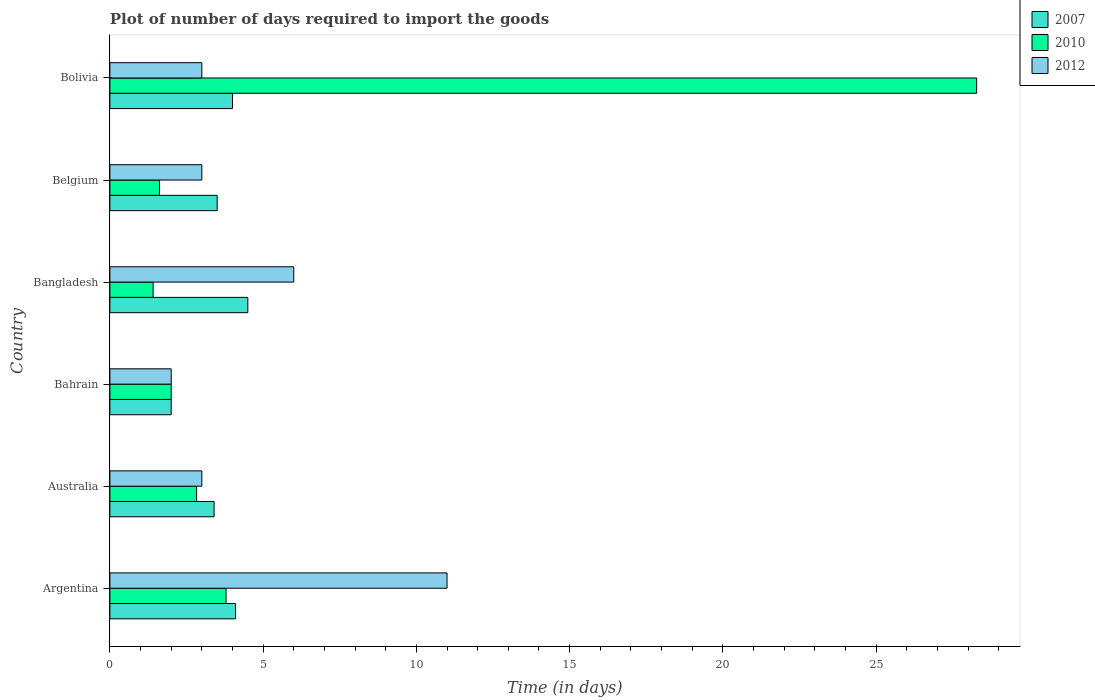How many groups of bars are there?
Offer a very short reply. 6. Are the number of bars on each tick of the Y-axis equal?
Offer a very short reply. Yes. How many bars are there on the 3rd tick from the top?
Your response must be concise. 3. How many bars are there on the 2nd tick from the bottom?
Make the answer very short. 3. What is the time required to import goods in 2010 in Bahrain?
Give a very brief answer. 2. Across all countries, what is the maximum time required to import goods in 2010?
Provide a succinct answer. 28.28. In which country was the time required to import goods in 2007 maximum?
Give a very brief answer. Bangladesh. In which country was the time required to import goods in 2007 minimum?
Offer a very short reply. Bahrain. What is the difference between the time required to import goods in 2007 in Bahrain and that in Bangladesh?
Offer a very short reply. -2.5. What is the difference between the time required to import goods in 2012 in Bangladesh and the time required to import goods in 2010 in Bolivia?
Ensure brevity in your answer.  -22.28. What is the average time required to import goods in 2012 per country?
Your answer should be very brief. 4.67. What is the difference between the time required to import goods in 2010 and time required to import goods in 2012 in Bolivia?
Offer a very short reply. 25.28. What is the ratio of the time required to import goods in 2007 in Australia to that in Bangladesh?
Your answer should be very brief. 0.76. Is the time required to import goods in 2012 in Bangladesh less than that in Bolivia?
Make the answer very short. No. Is the difference between the time required to import goods in 2010 in Australia and Bangladesh greater than the difference between the time required to import goods in 2012 in Australia and Bangladesh?
Provide a succinct answer. Yes. What is the difference between the highest and the second highest time required to import goods in 2010?
Make the answer very short. 24.49. Is it the case that in every country, the sum of the time required to import goods in 2007 and time required to import goods in 2012 is greater than the time required to import goods in 2010?
Your answer should be compact. No. How many bars are there?
Offer a very short reply. 18. How many countries are there in the graph?
Your response must be concise. 6. Are the values on the major ticks of X-axis written in scientific E-notation?
Keep it short and to the point. No. Does the graph contain grids?
Offer a very short reply. No. How many legend labels are there?
Your answer should be very brief. 3. How are the legend labels stacked?
Offer a terse response. Vertical. What is the title of the graph?
Keep it short and to the point. Plot of number of days required to import the goods. Does "1999" appear as one of the legend labels in the graph?
Offer a very short reply. No. What is the label or title of the X-axis?
Offer a terse response. Time (in days). What is the Time (in days) of 2010 in Argentina?
Your answer should be very brief. 3.79. What is the Time (in days) of 2012 in Argentina?
Give a very brief answer. 11. What is the Time (in days) of 2010 in Australia?
Your answer should be compact. 2.83. What is the Time (in days) of 2007 in Bahrain?
Make the answer very short. 2. What is the Time (in days) in 2010 in Bahrain?
Provide a succinct answer. 2. What is the Time (in days) of 2012 in Bahrain?
Give a very brief answer. 2. What is the Time (in days) in 2010 in Bangladesh?
Your answer should be compact. 1.41. What is the Time (in days) of 2012 in Bangladesh?
Give a very brief answer. 6. What is the Time (in days) of 2007 in Belgium?
Offer a very short reply. 3.5. What is the Time (in days) in 2010 in Belgium?
Your answer should be very brief. 1.62. What is the Time (in days) in 2012 in Belgium?
Provide a succinct answer. 3. What is the Time (in days) in 2007 in Bolivia?
Your answer should be very brief. 4. What is the Time (in days) of 2010 in Bolivia?
Your answer should be very brief. 28.28. What is the Time (in days) of 2012 in Bolivia?
Your answer should be compact. 3. Across all countries, what is the maximum Time (in days) in 2010?
Provide a succinct answer. 28.28. Across all countries, what is the minimum Time (in days) of 2010?
Provide a succinct answer. 1.41. Across all countries, what is the minimum Time (in days) in 2012?
Your answer should be very brief. 2. What is the total Time (in days) in 2010 in the graph?
Give a very brief answer. 39.93. What is the difference between the Time (in days) in 2007 in Argentina and that in Australia?
Make the answer very short. 0.7. What is the difference between the Time (in days) of 2012 in Argentina and that in Australia?
Your answer should be compact. 8. What is the difference between the Time (in days) in 2010 in Argentina and that in Bahrain?
Provide a succinct answer. 1.79. What is the difference between the Time (in days) in 2012 in Argentina and that in Bahrain?
Provide a succinct answer. 9. What is the difference between the Time (in days) in 2007 in Argentina and that in Bangladesh?
Provide a short and direct response. -0.4. What is the difference between the Time (in days) of 2010 in Argentina and that in Bangladesh?
Keep it short and to the point. 2.38. What is the difference between the Time (in days) in 2010 in Argentina and that in Belgium?
Offer a terse response. 2.17. What is the difference between the Time (in days) in 2007 in Argentina and that in Bolivia?
Provide a short and direct response. 0.1. What is the difference between the Time (in days) in 2010 in Argentina and that in Bolivia?
Ensure brevity in your answer.  -24.49. What is the difference between the Time (in days) of 2007 in Australia and that in Bahrain?
Your response must be concise. 1.4. What is the difference between the Time (in days) in 2010 in Australia and that in Bahrain?
Keep it short and to the point. 0.83. What is the difference between the Time (in days) of 2007 in Australia and that in Bangladesh?
Provide a short and direct response. -1.1. What is the difference between the Time (in days) in 2010 in Australia and that in Bangladesh?
Your answer should be compact. 1.42. What is the difference between the Time (in days) in 2012 in Australia and that in Bangladesh?
Make the answer very short. -3. What is the difference between the Time (in days) in 2010 in Australia and that in Belgium?
Your answer should be very brief. 1.21. What is the difference between the Time (in days) of 2012 in Australia and that in Belgium?
Give a very brief answer. 0. What is the difference between the Time (in days) in 2007 in Australia and that in Bolivia?
Offer a terse response. -0.6. What is the difference between the Time (in days) of 2010 in Australia and that in Bolivia?
Your response must be concise. -25.45. What is the difference between the Time (in days) of 2012 in Australia and that in Bolivia?
Offer a terse response. 0. What is the difference between the Time (in days) in 2007 in Bahrain and that in Bangladesh?
Offer a terse response. -2.5. What is the difference between the Time (in days) of 2010 in Bahrain and that in Bangladesh?
Your response must be concise. 0.59. What is the difference between the Time (in days) in 2012 in Bahrain and that in Bangladesh?
Your answer should be compact. -4. What is the difference between the Time (in days) of 2007 in Bahrain and that in Belgium?
Ensure brevity in your answer.  -1.5. What is the difference between the Time (in days) in 2010 in Bahrain and that in Belgium?
Offer a very short reply. 0.38. What is the difference between the Time (in days) of 2010 in Bahrain and that in Bolivia?
Your response must be concise. -26.28. What is the difference between the Time (in days) of 2010 in Bangladesh and that in Belgium?
Offer a very short reply. -0.21. What is the difference between the Time (in days) of 2007 in Bangladesh and that in Bolivia?
Your answer should be compact. 0.5. What is the difference between the Time (in days) of 2010 in Bangladesh and that in Bolivia?
Your answer should be very brief. -26.87. What is the difference between the Time (in days) of 2010 in Belgium and that in Bolivia?
Your response must be concise. -26.66. What is the difference between the Time (in days) of 2012 in Belgium and that in Bolivia?
Your response must be concise. 0. What is the difference between the Time (in days) of 2007 in Argentina and the Time (in days) of 2010 in Australia?
Your response must be concise. 1.27. What is the difference between the Time (in days) of 2010 in Argentina and the Time (in days) of 2012 in Australia?
Provide a succinct answer. 0.79. What is the difference between the Time (in days) of 2007 in Argentina and the Time (in days) of 2012 in Bahrain?
Keep it short and to the point. 2.1. What is the difference between the Time (in days) of 2010 in Argentina and the Time (in days) of 2012 in Bahrain?
Make the answer very short. 1.79. What is the difference between the Time (in days) of 2007 in Argentina and the Time (in days) of 2010 in Bangladesh?
Give a very brief answer. 2.69. What is the difference between the Time (in days) in 2007 in Argentina and the Time (in days) in 2012 in Bangladesh?
Make the answer very short. -1.9. What is the difference between the Time (in days) in 2010 in Argentina and the Time (in days) in 2012 in Bangladesh?
Give a very brief answer. -2.21. What is the difference between the Time (in days) of 2007 in Argentina and the Time (in days) of 2010 in Belgium?
Ensure brevity in your answer.  2.48. What is the difference between the Time (in days) of 2007 in Argentina and the Time (in days) of 2012 in Belgium?
Give a very brief answer. 1.1. What is the difference between the Time (in days) of 2010 in Argentina and the Time (in days) of 2012 in Belgium?
Offer a very short reply. 0.79. What is the difference between the Time (in days) in 2007 in Argentina and the Time (in days) in 2010 in Bolivia?
Ensure brevity in your answer.  -24.18. What is the difference between the Time (in days) in 2007 in Argentina and the Time (in days) in 2012 in Bolivia?
Offer a terse response. 1.1. What is the difference between the Time (in days) in 2010 in Argentina and the Time (in days) in 2012 in Bolivia?
Your answer should be very brief. 0.79. What is the difference between the Time (in days) in 2010 in Australia and the Time (in days) in 2012 in Bahrain?
Offer a very short reply. 0.83. What is the difference between the Time (in days) of 2007 in Australia and the Time (in days) of 2010 in Bangladesh?
Make the answer very short. 1.99. What is the difference between the Time (in days) of 2007 in Australia and the Time (in days) of 2012 in Bangladesh?
Offer a terse response. -2.6. What is the difference between the Time (in days) in 2010 in Australia and the Time (in days) in 2012 in Bangladesh?
Your answer should be very brief. -3.17. What is the difference between the Time (in days) of 2007 in Australia and the Time (in days) of 2010 in Belgium?
Ensure brevity in your answer.  1.78. What is the difference between the Time (in days) of 2010 in Australia and the Time (in days) of 2012 in Belgium?
Make the answer very short. -0.17. What is the difference between the Time (in days) of 2007 in Australia and the Time (in days) of 2010 in Bolivia?
Offer a very short reply. -24.88. What is the difference between the Time (in days) in 2010 in Australia and the Time (in days) in 2012 in Bolivia?
Make the answer very short. -0.17. What is the difference between the Time (in days) of 2007 in Bahrain and the Time (in days) of 2010 in Bangladesh?
Ensure brevity in your answer.  0.59. What is the difference between the Time (in days) in 2007 in Bahrain and the Time (in days) in 2012 in Bangladesh?
Your answer should be compact. -4. What is the difference between the Time (in days) of 2007 in Bahrain and the Time (in days) of 2010 in Belgium?
Offer a very short reply. 0.38. What is the difference between the Time (in days) of 2007 in Bahrain and the Time (in days) of 2012 in Belgium?
Your response must be concise. -1. What is the difference between the Time (in days) of 2010 in Bahrain and the Time (in days) of 2012 in Belgium?
Ensure brevity in your answer.  -1. What is the difference between the Time (in days) of 2007 in Bahrain and the Time (in days) of 2010 in Bolivia?
Offer a terse response. -26.28. What is the difference between the Time (in days) of 2010 in Bahrain and the Time (in days) of 2012 in Bolivia?
Offer a terse response. -1. What is the difference between the Time (in days) of 2007 in Bangladesh and the Time (in days) of 2010 in Belgium?
Your answer should be compact. 2.88. What is the difference between the Time (in days) in 2007 in Bangladesh and the Time (in days) in 2012 in Belgium?
Make the answer very short. 1.5. What is the difference between the Time (in days) of 2010 in Bangladesh and the Time (in days) of 2012 in Belgium?
Keep it short and to the point. -1.59. What is the difference between the Time (in days) in 2007 in Bangladesh and the Time (in days) in 2010 in Bolivia?
Your answer should be compact. -23.78. What is the difference between the Time (in days) of 2010 in Bangladesh and the Time (in days) of 2012 in Bolivia?
Provide a succinct answer. -1.59. What is the difference between the Time (in days) of 2007 in Belgium and the Time (in days) of 2010 in Bolivia?
Offer a very short reply. -24.78. What is the difference between the Time (in days) of 2010 in Belgium and the Time (in days) of 2012 in Bolivia?
Provide a short and direct response. -1.38. What is the average Time (in days) in 2007 per country?
Ensure brevity in your answer.  3.58. What is the average Time (in days) in 2010 per country?
Offer a very short reply. 6.66. What is the average Time (in days) of 2012 per country?
Your answer should be compact. 4.67. What is the difference between the Time (in days) in 2007 and Time (in days) in 2010 in Argentina?
Offer a terse response. 0.31. What is the difference between the Time (in days) in 2007 and Time (in days) in 2012 in Argentina?
Give a very brief answer. -6.9. What is the difference between the Time (in days) of 2010 and Time (in days) of 2012 in Argentina?
Provide a short and direct response. -7.21. What is the difference between the Time (in days) of 2007 and Time (in days) of 2010 in Australia?
Keep it short and to the point. 0.57. What is the difference between the Time (in days) of 2007 and Time (in days) of 2012 in Australia?
Your answer should be very brief. 0.4. What is the difference between the Time (in days) in 2010 and Time (in days) in 2012 in Australia?
Your answer should be compact. -0.17. What is the difference between the Time (in days) of 2007 and Time (in days) of 2010 in Bahrain?
Make the answer very short. 0. What is the difference between the Time (in days) in 2007 and Time (in days) in 2010 in Bangladesh?
Provide a short and direct response. 3.09. What is the difference between the Time (in days) in 2007 and Time (in days) in 2012 in Bangladesh?
Give a very brief answer. -1.5. What is the difference between the Time (in days) in 2010 and Time (in days) in 2012 in Bangladesh?
Make the answer very short. -4.59. What is the difference between the Time (in days) of 2007 and Time (in days) of 2010 in Belgium?
Offer a terse response. 1.88. What is the difference between the Time (in days) in 2007 and Time (in days) in 2012 in Belgium?
Provide a short and direct response. 0.5. What is the difference between the Time (in days) of 2010 and Time (in days) of 2012 in Belgium?
Provide a succinct answer. -1.38. What is the difference between the Time (in days) of 2007 and Time (in days) of 2010 in Bolivia?
Ensure brevity in your answer.  -24.28. What is the difference between the Time (in days) in 2010 and Time (in days) in 2012 in Bolivia?
Make the answer very short. 25.28. What is the ratio of the Time (in days) of 2007 in Argentina to that in Australia?
Your answer should be very brief. 1.21. What is the ratio of the Time (in days) in 2010 in Argentina to that in Australia?
Make the answer very short. 1.34. What is the ratio of the Time (in days) of 2012 in Argentina to that in Australia?
Make the answer very short. 3.67. What is the ratio of the Time (in days) in 2007 in Argentina to that in Bahrain?
Provide a short and direct response. 2.05. What is the ratio of the Time (in days) of 2010 in Argentina to that in Bahrain?
Your answer should be very brief. 1.9. What is the ratio of the Time (in days) of 2012 in Argentina to that in Bahrain?
Ensure brevity in your answer.  5.5. What is the ratio of the Time (in days) in 2007 in Argentina to that in Bangladesh?
Your answer should be compact. 0.91. What is the ratio of the Time (in days) of 2010 in Argentina to that in Bangladesh?
Your response must be concise. 2.69. What is the ratio of the Time (in days) in 2012 in Argentina to that in Bangladesh?
Your answer should be compact. 1.83. What is the ratio of the Time (in days) of 2007 in Argentina to that in Belgium?
Ensure brevity in your answer.  1.17. What is the ratio of the Time (in days) in 2010 in Argentina to that in Belgium?
Give a very brief answer. 2.34. What is the ratio of the Time (in days) of 2012 in Argentina to that in Belgium?
Give a very brief answer. 3.67. What is the ratio of the Time (in days) in 2007 in Argentina to that in Bolivia?
Give a very brief answer. 1.02. What is the ratio of the Time (in days) of 2010 in Argentina to that in Bolivia?
Make the answer very short. 0.13. What is the ratio of the Time (in days) in 2012 in Argentina to that in Bolivia?
Your answer should be very brief. 3.67. What is the ratio of the Time (in days) of 2010 in Australia to that in Bahrain?
Offer a terse response. 1.42. What is the ratio of the Time (in days) of 2012 in Australia to that in Bahrain?
Keep it short and to the point. 1.5. What is the ratio of the Time (in days) in 2007 in Australia to that in Bangladesh?
Give a very brief answer. 0.76. What is the ratio of the Time (in days) of 2010 in Australia to that in Bangladesh?
Provide a succinct answer. 2.01. What is the ratio of the Time (in days) in 2007 in Australia to that in Belgium?
Ensure brevity in your answer.  0.97. What is the ratio of the Time (in days) in 2010 in Australia to that in Belgium?
Your answer should be very brief. 1.75. What is the ratio of the Time (in days) of 2010 in Australia to that in Bolivia?
Your response must be concise. 0.1. What is the ratio of the Time (in days) in 2007 in Bahrain to that in Bangladesh?
Your answer should be very brief. 0.44. What is the ratio of the Time (in days) of 2010 in Bahrain to that in Bangladesh?
Ensure brevity in your answer.  1.42. What is the ratio of the Time (in days) of 2007 in Bahrain to that in Belgium?
Your answer should be very brief. 0.57. What is the ratio of the Time (in days) in 2010 in Bahrain to that in Belgium?
Your answer should be very brief. 1.23. What is the ratio of the Time (in days) in 2012 in Bahrain to that in Belgium?
Ensure brevity in your answer.  0.67. What is the ratio of the Time (in days) in 2007 in Bahrain to that in Bolivia?
Your answer should be compact. 0.5. What is the ratio of the Time (in days) of 2010 in Bahrain to that in Bolivia?
Offer a terse response. 0.07. What is the ratio of the Time (in days) of 2010 in Bangladesh to that in Belgium?
Keep it short and to the point. 0.87. What is the ratio of the Time (in days) in 2010 in Bangladesh to that in Bolivia?
Your answer should be very brief. 0.05. What is the ratio of the Time (in days) of 2010 in Belgium to that in Bolivia?
Your response must be concise. 0.06. What is the ratio of the Time (in days) of 2012 in Belgium to that in Bolivia?
Your answer should be compact. 1. What is the difference between the highest and the second highest Time (in days) in 2010?
Provide a short and direct response. 24.49. What is the difference between the highest and the lowest Time (in days) of 2007?
Keep it short and to the point. 2.5. What is the difference between the highest and the lowest Time (in days) in 2010?
Keep it short and to the point. 26.87. 